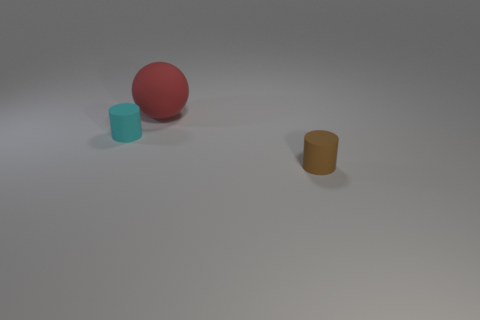What objects can you identify in this image? In the image, there is a blue cylinder, a red sphere, and a yellow-golden cylinder all placed on a light surface with a greyish background. 